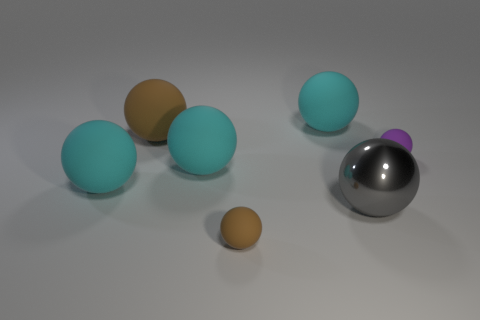Subtract all purple balls. How many balls are left? 6 Subtract all blue cylinders. How many brown spheres are left? 2 Add 2 small purple rubber things. How many objects exist? 9 Subtract all gray spheres. How many spheres are left? 6 Subtract 3 spheres. How many spheres are left? 4 Subtract all red balls. Subtract all cyan cylinders. How many balls are left? 7 Subtract all gray metallic spheres. Subtract all big cyan rubber things. How many objects are left? 3 Add 2 metal objects. How many metal objects are left? 3 Add 7 gray balls. How many gray balls exist? 8 Subtract 1 gray balls. How many objects are left? 6 